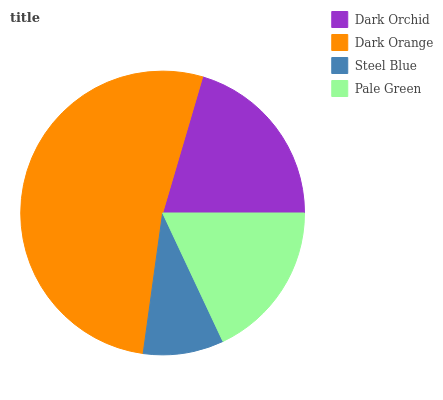Is Steel Blue the minimum?
Answer yes or no. Yes. Is Dark Orange the maximum?
Answer yes or no. Yes. Is Dark Orange the minimum?
Answer yes or no. No. Is Steel Blue the maximum?
Answer yes or no. No. Is Dark Orange greater than Steel Blue?
Answer yes or no. Yes. Is Steel Blue less than Dark Orange?
Answer yes or no. Yes. Is Steel Blue greater than Dark Orange?
Answer yes or no. No. Is Dark Orange less than Steel Blue?
Answer yes or no. No. Is Dark Orchid the high median?
Answer yes or no. Yes. Is Pale Green the low median?
Answer yes or no. Yes. Is Dark Orange the high median?
Answer yes or no. No. Is Dark Orchid the low median?
Answer yes or no. No. 